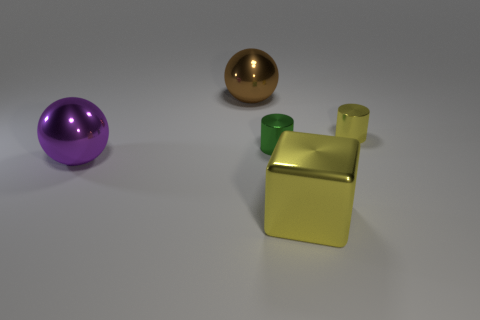Add 1 big red cylinders. How many objects exist? 6 Subtract all spheres. How many objects are left? 3 Add 5 big metallic blocks. How many big metallic blocks are left? 6 Add 1 big brown shiny things. How many big brown shiny things exist? 2 Subtract 0 purple cylinders. How many objects are left? 5 Subtract all tiny green shiny cylinders. Subtract all big yellow objects. How many objects are left? 3 